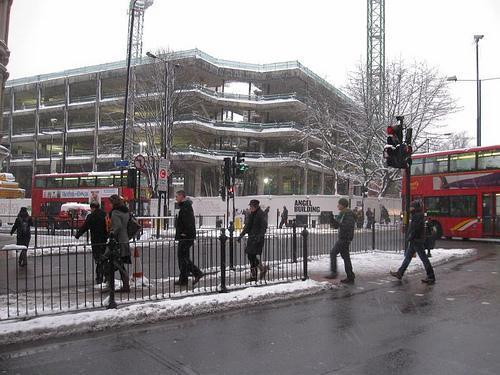How many buses can be seen?
Give a very brief answer. 2. 